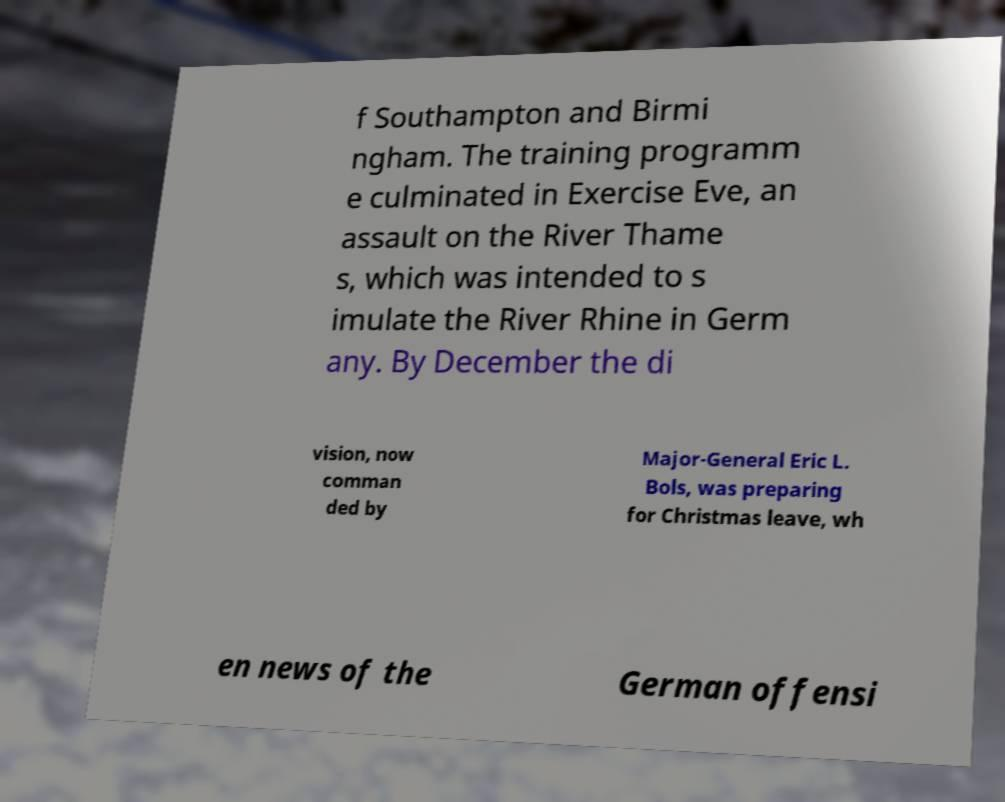Please identify and transcribe the text found in this image. f Southampton and Birmi ngham. The training programm e culminated in Exercise Eve, an assault on the River Thame s, which was intended to s imulate the River Rhine in Germ any. By December the di vision, now comman ded by Major-General Eric L. Bols, was preparing for Christmas leave, wh en news of the German offensi 